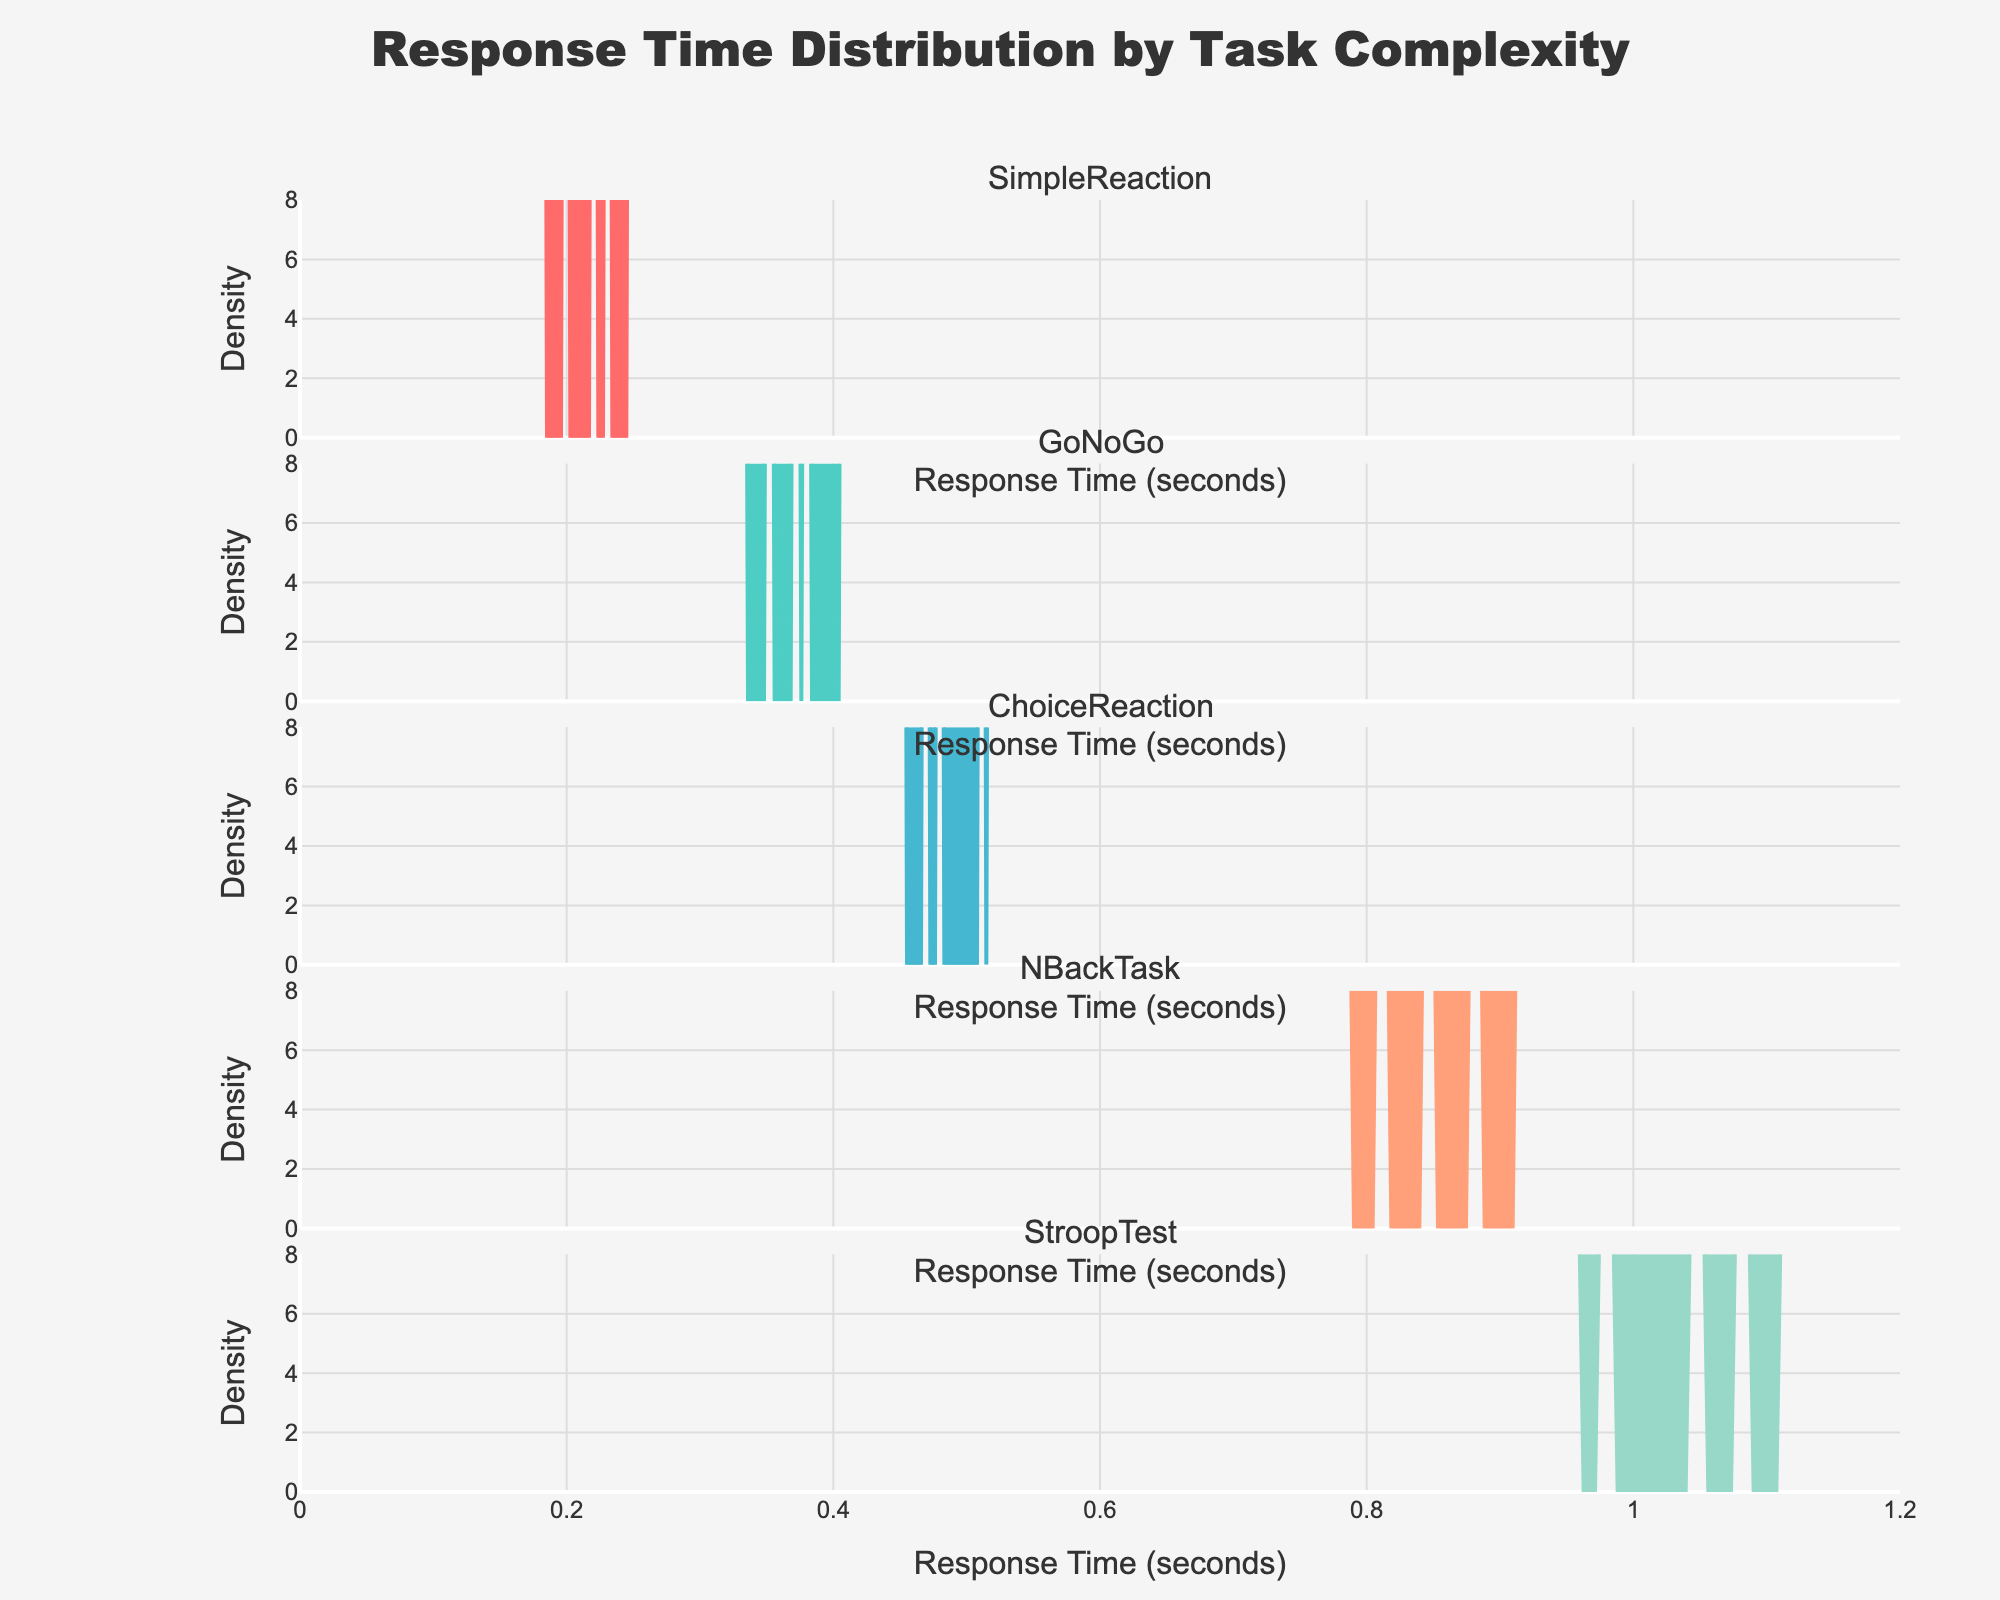What is the title of the plot? The title is usually displayed at the top of the plot, providing a concise description of what the figure represents. Here, it is "Response Time Distribution by Task Complexity".
Answer: Response Time Distribution by Task Complexity Which task has the highest peak density? To determine which task has the highest peak density, identify the density curves for each task and compare their maximum y-values. The task with the highest y-value at its peak represents the highest peak density.
Answer: StroopTest What is the range of the x-axis? The range of the x-axis can be determined by looking at the minimum and maximum x-axis values labeled on the plot. Here, it ranges from 0 to 1.2 seconds.
Answer: 0 to 1.2 seconds Which task category has the smallest spread in response times? To find the task with the smallest spread, examine the width of each density plot. The task with the narrowest spread along the x-axis signifies the smallest spread in response times.
Answer: SimpleReaction What is the median response time for the ChoiceReaction task? By looking at the density plot of the ChoiceReaction task, the median would be around the center of the peak. Given the values plotted, the median can be estimated at approximately 0.48 to 0.50 seconds.
Answer: 0.48 to 0.50 seconds Which task shows the slowest response times on average? Identify the task with the highest values along the x-axis consistently. This is the task with denser distribution at higher response times. The StroopTest, with its density concentrated around 0.95 to 1.12 seconds, indicates the slowest average response time.
Answer: StroopTest What is the shape of the response time distribution for the GoNoGo task? Examine the GoNoGo density plot to describe its shape. The density curve appears to be moderately symmetric with a peak around the center, suggesting a normal-like distribution.
Answer: Moderately symmetric / Normal-like Between the SimpleReaction and NBackTask, which category has more variability in response times? Compare the spread of the density plots for SimpleReaction and NBackTask. The NBackTask shows a wider range across the x-axis, suggesting greater variability in response times.
Answer: NBackTask Which task has the peak density closest to a response time of 0.4 seconds? Identify the peak density of each task and see which one is closest to 0.4 seconds on the x-axis. The GoNoGo task has its peak density nearest to this value.
Answer: GoNoGo How many distinct tasks are compared in this plot? Count the number of unique subplot titles or density curves present in the figure. There are five distinct tasks being compared.
Answer: Five 